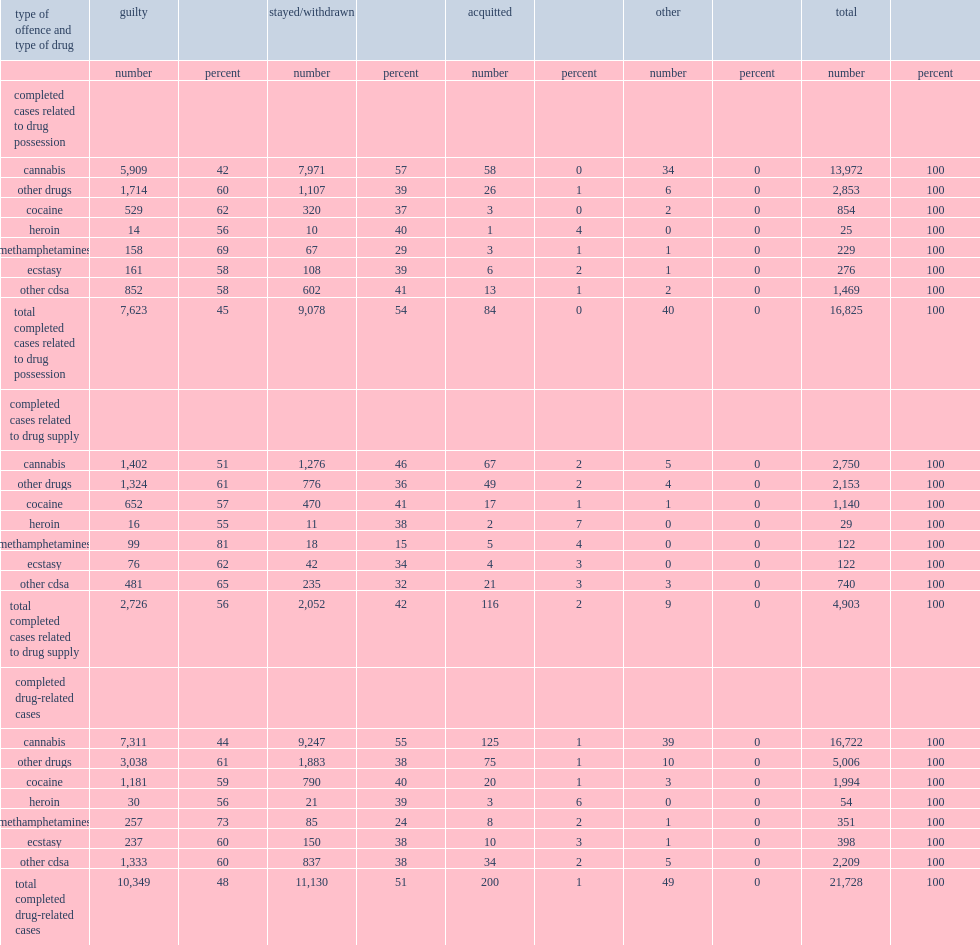Youth courts reported similar breakdowns of decisions by type of drug and by type of offence,what is the percentage of all completed cases resulting in a decision of guilt from 2008/2009 to 2011/2012? 48.0. What is the percentage of the cases related to the possession of cannabis resulted in a finding of guilt from 2008/2009 to 2011/2012? 42.0. What is the percentage of the cases related to the supply of cannabis resulted in a finding of guilt from 2008/2009 to 2011/2012? 51.0. What is the percentage of the cases related to the supply of other drugs resulted in a finding of guilt from 2008/2009 to 2011/2012? 61.0. What is the percentage of the cases related to the possession of other drugs resulted in a finding of guilt from 2008/2009 to 2011/2012? 60.0. What is the percentage of completed drug-related cases involving methamphetamines resulted in a decision of guilt in youth court from 2008/2009 to 2011/2012? 73.0. 